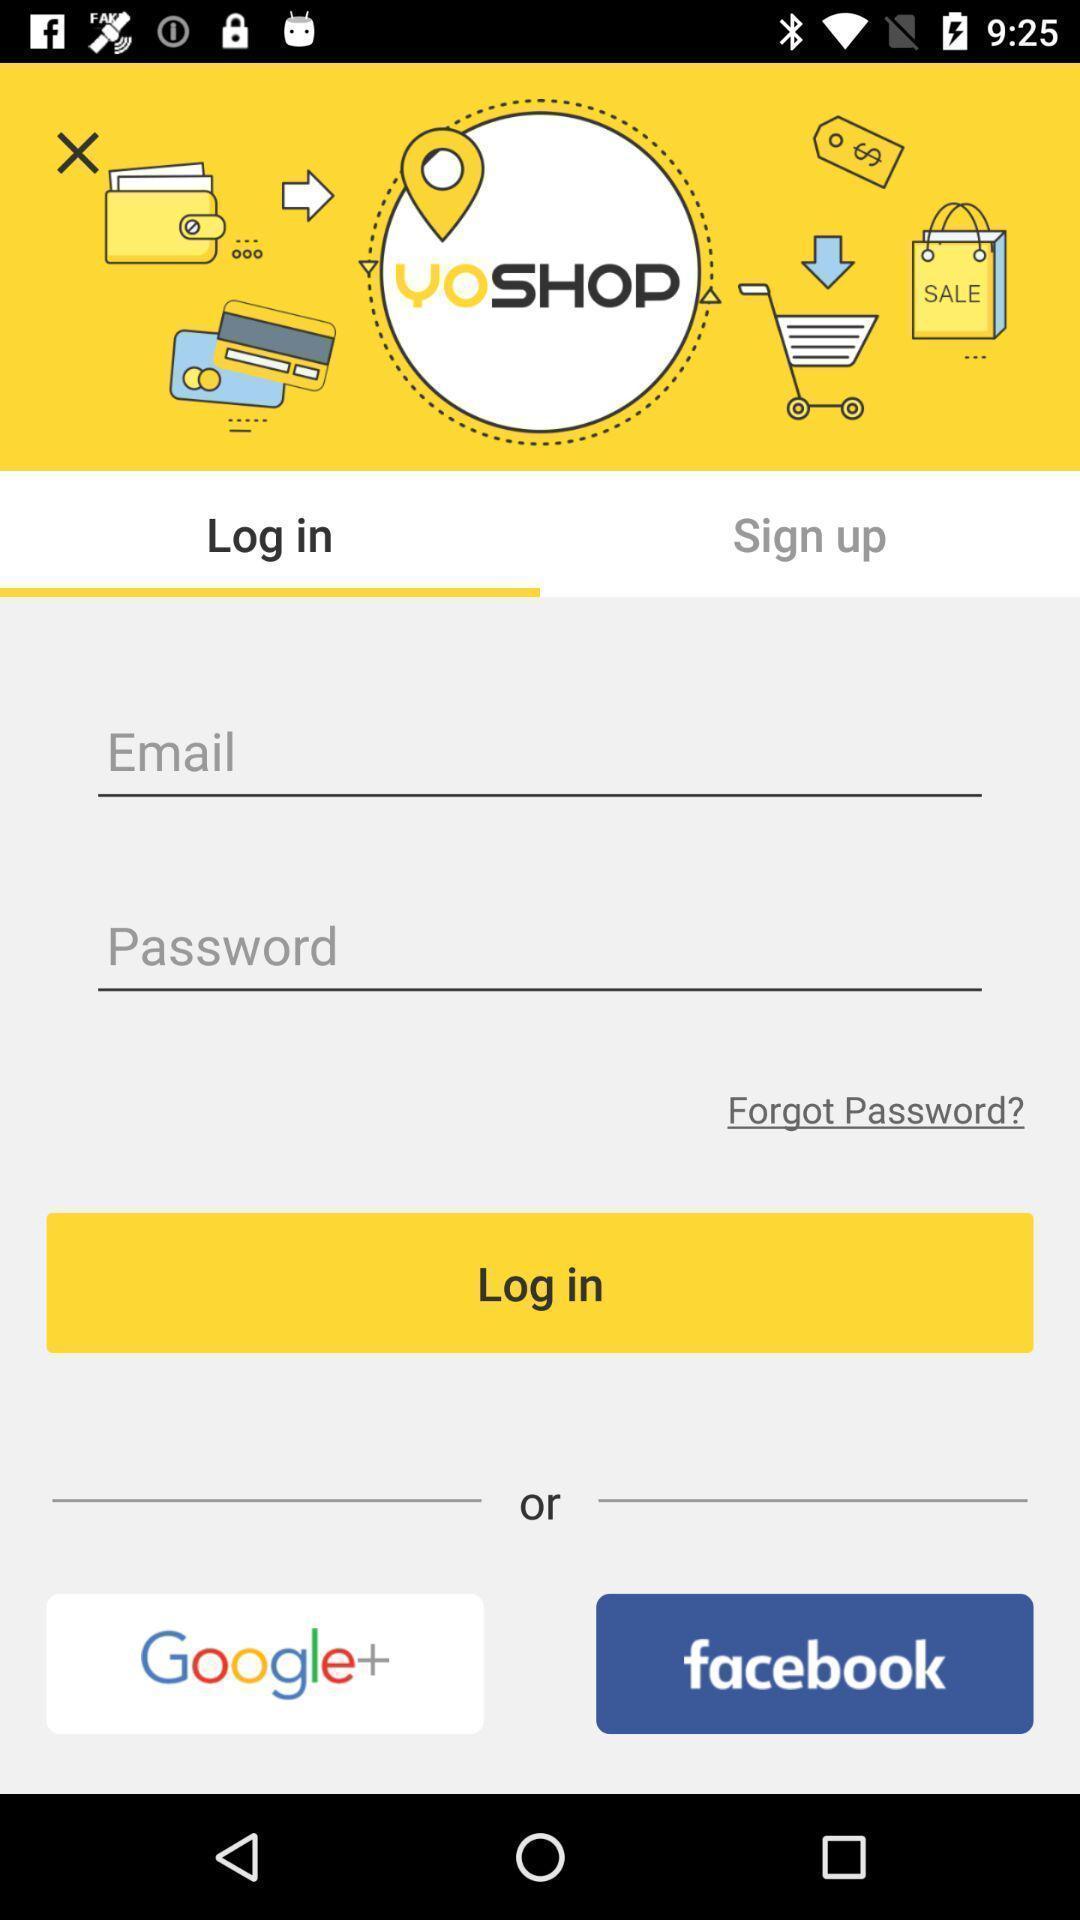Describe this image in words. Screen displaying multiple login options in a shopping application. 